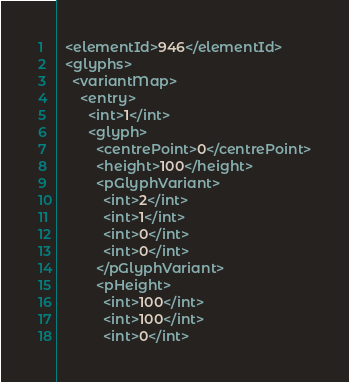<code> <loc_0><loc_0><loc_500><loc_500><_XML_>  <elementId>946</elementId>
  <glyphs>
    <variantMap>
      <entry>
        <int>1</int>
        <glyph>
          <centrePoint>0</centrePoint>
          <height>100</height>
          <pGlyphVariant>
            <int>2</int>
            <int>1</int>
            <int>0</int>
            <int>0</int>
          </pGlyphVariant>
          <pHeight>
            <int>100</int>
            <int>100</int>
            <int>0</int></code> 